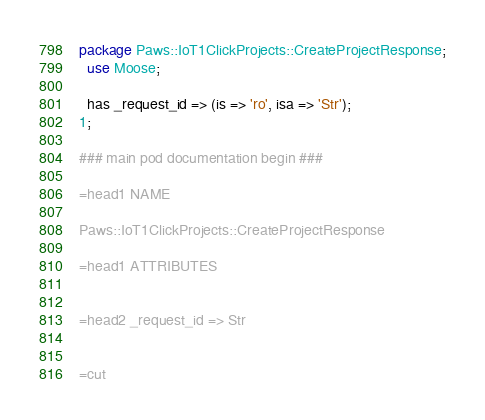Convert code to text. <code><loc_0><loc_0><loc_500><loc_500><_Perl_>
package Paws::IoT1ClickProjects::CreateProjectResponse;
  use Moose;

  has _request_id => (is => 'ro', isa => 'Str');
1;

### main pod documentation begin ###

=head1 NAME

Paws::IoT1ClickProjects::CreateProjectResponse

=head1 ATTRIBUTES


=head2 _request_id => Str


=cut

</code> 